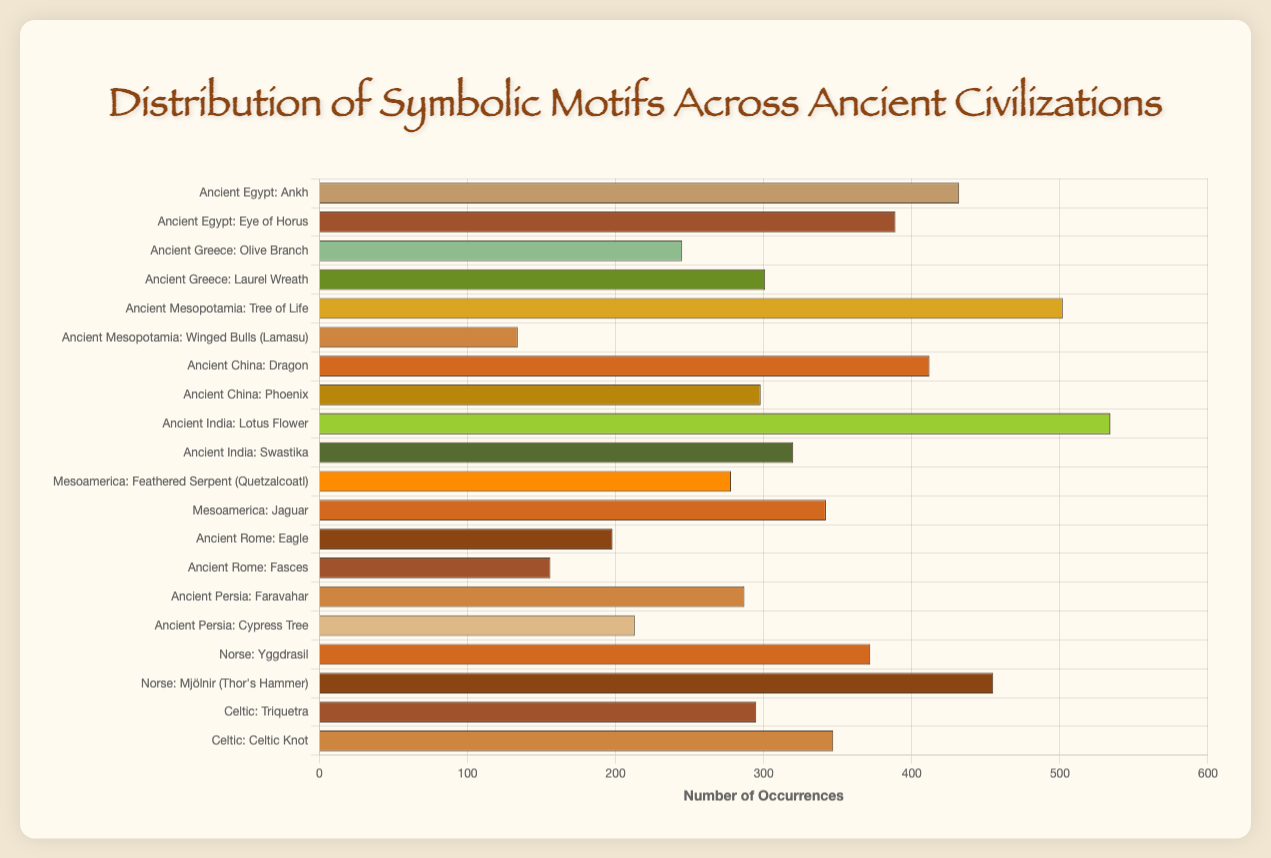What's the most frequently occurring symbolic motif in the dataset? By looking at the horizontal bar chart, we find the longest bar, which represents the number of occurrences. The motif with the longest bar is the Lotus Flower from Ancient India.
Answer: Lotus Flower (534 occurrences) Which civilization has the highest combined occurrences of motifs? To determine this, sum the occurrences of all motifs within each civilization. The civilization with the highest total is Ancient India, with Lotus Flower (534) and Swastika (320), for a combined total of 854.
Answer: Ancient India (854 occurrences) Compare the occurrences of the motifs from Ancient Rome and Ancient Persia. Which civilization has a higher total? First, sum the occurrences of motifs for each civilization. Ancient Rome has Eagle (198) and Fasces (156), totaling 354. Ancient Persia has Faravahar (287) and Cypress Tree (213), totaling 500. Ancient Persia has a higher total.
Answer: Ancient Persia (500 occurrences) What is the combined number of occurrences of motifs from the Norse civilization compared to the Celtic civilization? Summing the occurrences for the Norse: Yggdrasil (372) + Mjölnir (455) = 827. For the Celtic: Triquetra (295) + Celtic Knot (347) = 642. The Norse civilization has a higher combined total.
Answer: Norse: 827, Celtic: 642 Considering visual attributes, which civilization's motif has the longest bar in the figure? The longest bar represents the motif with the most occurrences. Observing the bars, the Lotus Flower from Ancient India has the longest bar.
Answer: Lotus Flower (Ancient India) Calculate the average number of occurrences for the motifs in Ancient Mesopotamia. Sum the occurrences for motifs in Ancient Mesopotamia: Tree of Life (502) + Winged Bulls (134) = 636. Divide by the number of motifs: 636 / 2 = 318.
Answer: 318 occurrences Which motif has the closest number of occurrences to the average number of occurrences for all motifs? First, find the total occurrences of all motifs and divide by the number of motifs: (432 + 389 + 245 + 301 + 502 + 134 + 412 + 298 + 534 + 320 + 278 + 342 + 198 + 156 + 287 + 213 + 372 + 455 + 295 + 347) / 20 = 340.15. The closest motif is Jaguar (342).
Answer: Jaguar (342 occurrences) What is the sum of occurrences for all symbolic motifs from Ancient China? Add the occurrences of Dragon (412) and Phoenix (298): 412 + 298 = 710.
Answer: 710 occurrences Which civilization’s symbolic motifs have occurrences that vary the most? Calculate the standard deviation for the occurrences in each civilization. Ancient Egypt: Ankh (432), Eye of Horus (389), variance = (432-410.5)^2 + (389-410.5)^2 = 922.25, std_dev = sqrt(922.25/2) = 30.36. This calculation is tedious; from looking at the figure, Ancient Mesopotamia has the biggest visual discrepancy between the two motifs' occurrences (502 and 134).
Answer: Ancient Mesopotamia What is the difference in occurrences between the most frequent and least frequent motifs overall? The most frequent motif is the Lotus Flower (534), and the least frequent is Winged Bulls (134). The difference is 534 - 134 = 400.
Answer: 400 occurrences 